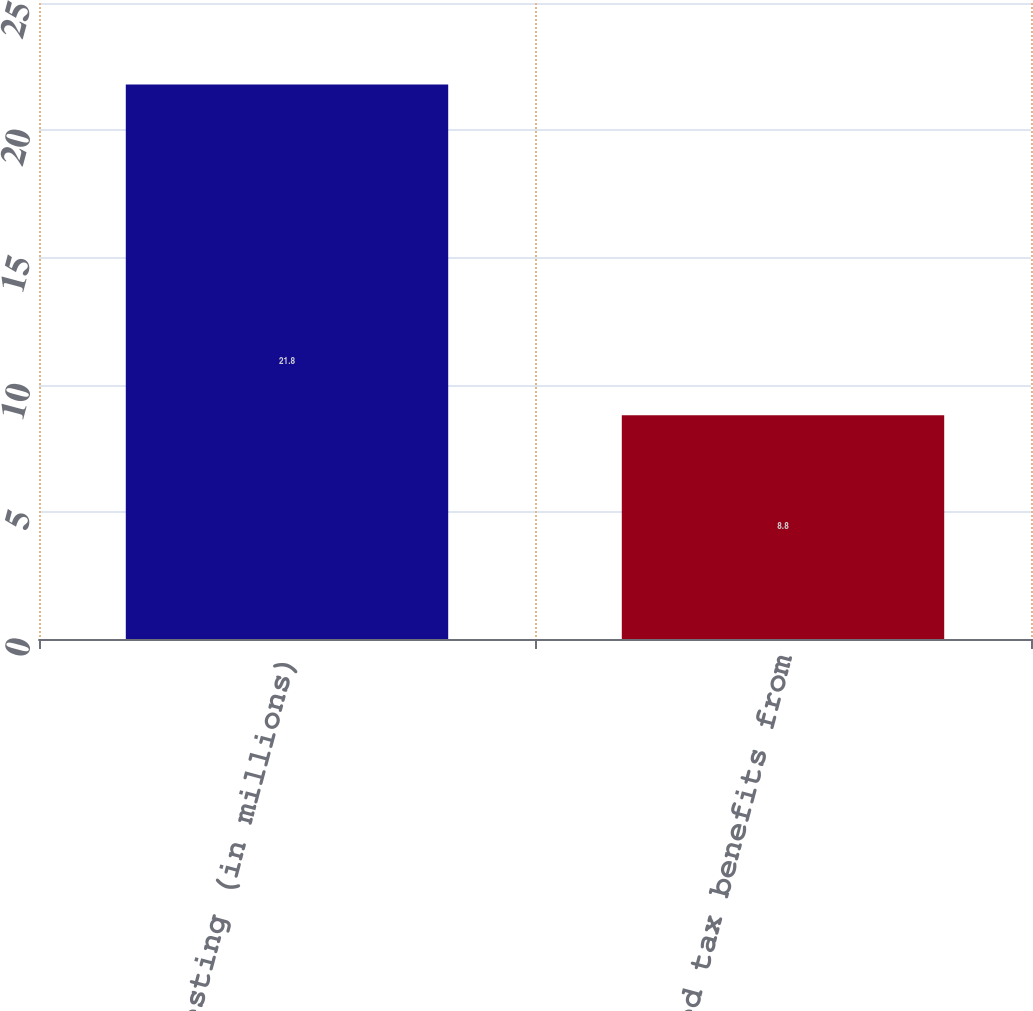<chart> <loc_0><loc_0><loc_500><loc_500><bar_chart><fcel>vesting (in millions)<fcel>Realized tax benefits from<nl><fcel>21.8<fcel>8.8<nl></chart> 